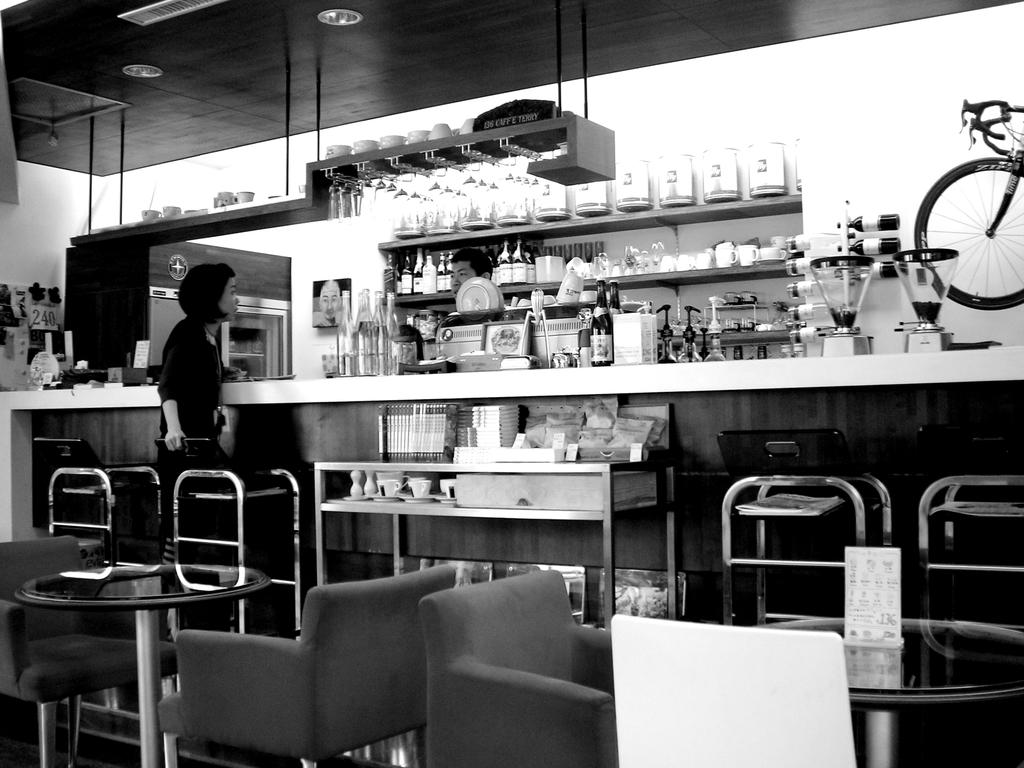What is the main setting of the image? There is a room in the image. Who or what can be seen in the room? A person is standing in the room, and they are holding a chair. What other furniture is present in the room? There is a table in the room. What is on the table? There is a poster on the table. Can you describe the background of the image? In the background, there is another person, lights are visible, jars are present, and a bicycle is visible. What type of cherry is being offered by the beggar in the image? There is no beggar or cherry present in the image. 